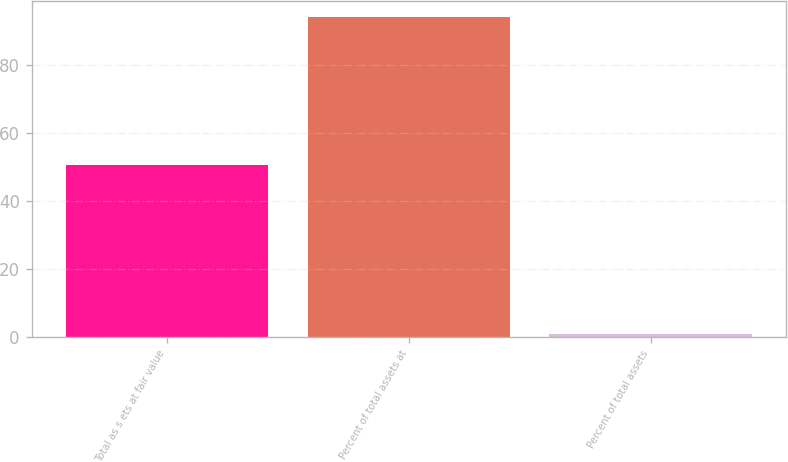Convert chart to OTSL. <chart><loc_0><loc_0><loc_500><loc_500><bar_chart><fcel>Total as s ets at fair value<fcel>Percent of total assets at<fcel>Percent of total assets<nl><fcel>50.6<fcel>94<fcel>0.7<nl></chart> 